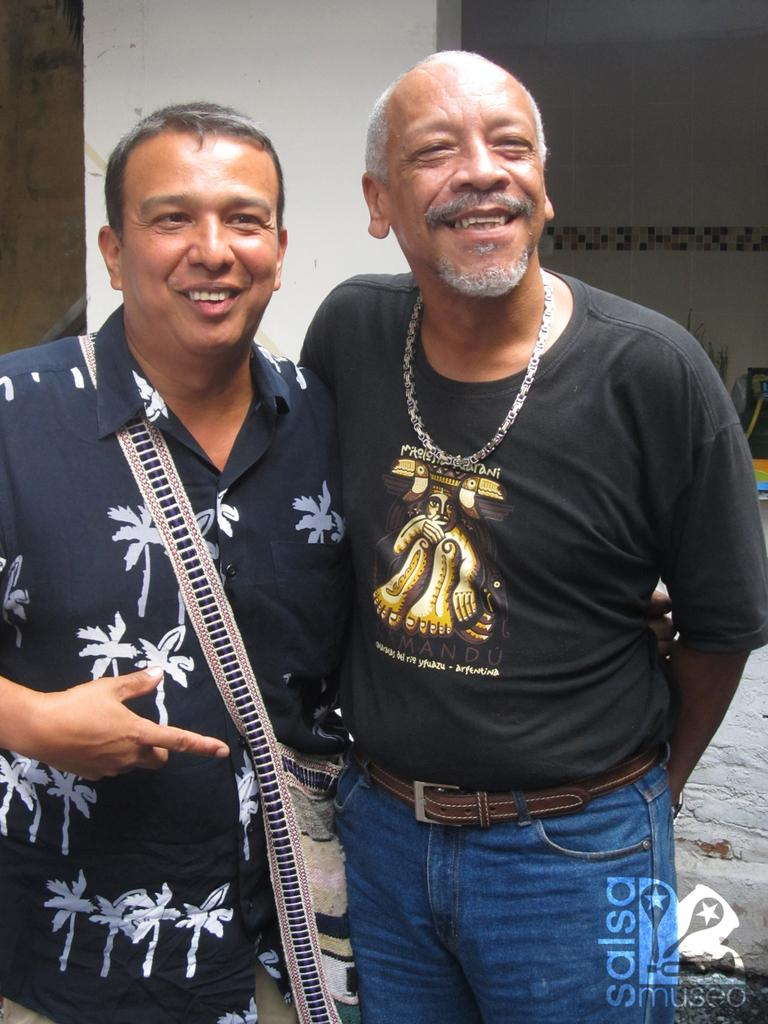How many people are present in the image? There are two people standing in the image. What is the facial expression of the people in the image? The people are smiling. What can be seen at the bottom of the image? There is a logo with text at the bottom of the image. What architectural feature is visible in the background of the image? There is a pillar in the background of the image. What type of wall can be seen in the background of the image? There is a tile wall in the background of the image. What type of slope can be seen in the image? There is no slope present in the image. What is being served for dinner in the image? There is no dinner being served in the image. 